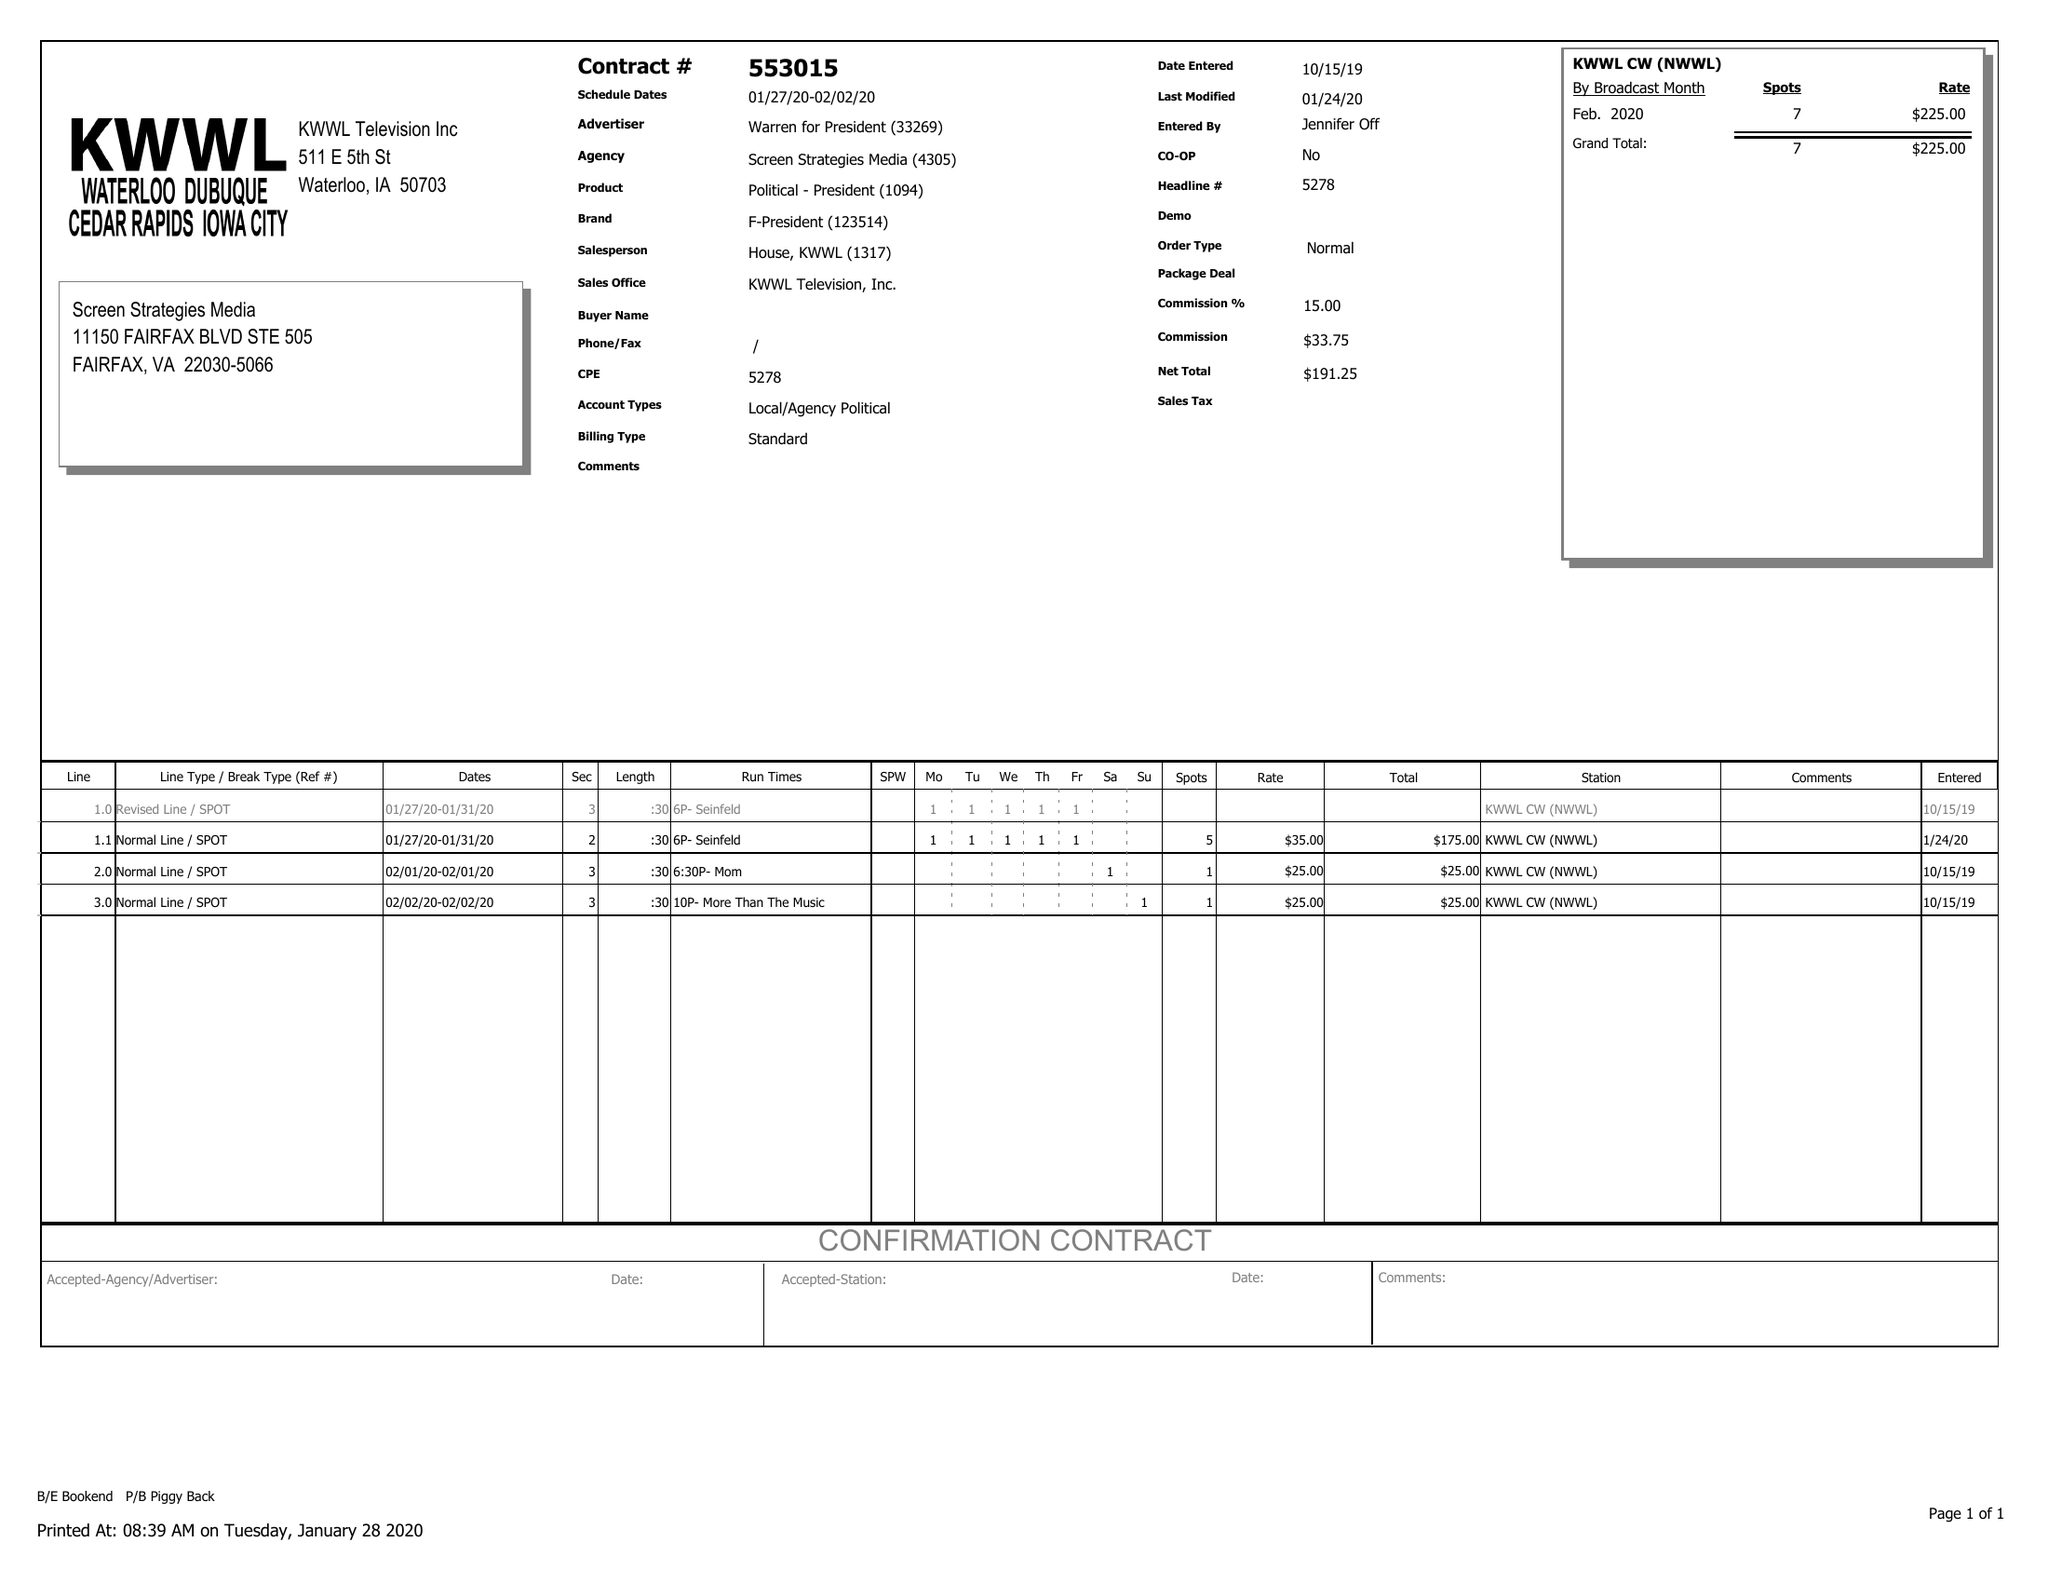What is the value for the advertiser?
Answer the question using a single word or phrase. WARREN FOR PRESIDENT 